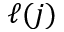Convert formula to latex. <formula><loc_0><loc_0><loc_500><loc_500>\ell ( j )</formula> 